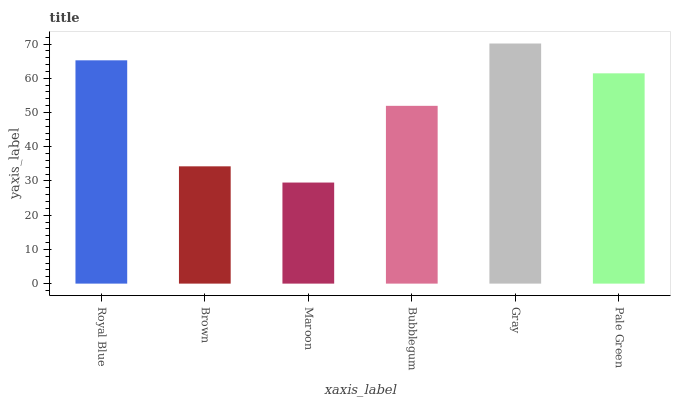Is Maroon the minimum?
Answer yes or no. Yes. Is Gray the maximum?
Answer yes or no. Yes. Is Brown the minimum?
Answer yes or no. No. Is Brown the maximum?
Answer yes or no. No. Is Royal Blue greater than Brown?
Answer yes or no. Yes. Is Brown less than Royal Blue?
Answer yes or no. Yes. Is Brown greater than Royal Blue?
Answer yes or no. No. Is Royal Blue less than Brown?
Answer yes or no. No. Is Pale Green the high median?
Answer yes or no. Yes. Is Bubblegum the low median?
Answer yes or no. Yes. Is Royal Blue the high median?
Answer yes or no. No. Is Pale Green the low median?
Answer yes or no. No. 